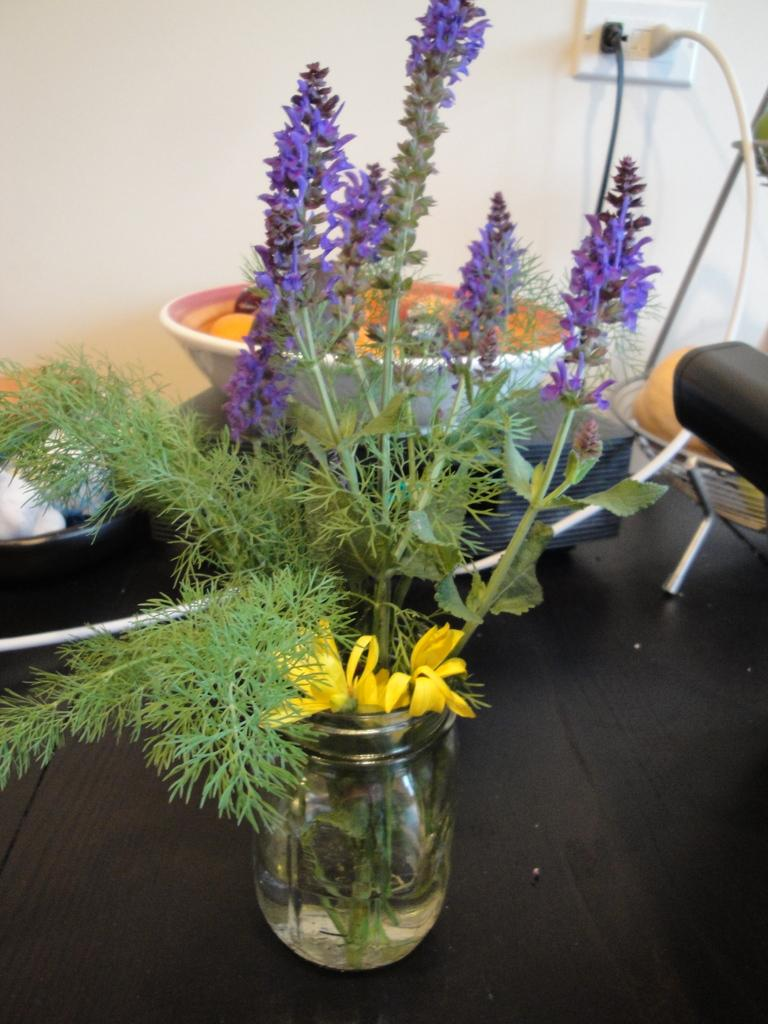What type of plant can be seen in the image? There is a plant with a flower in the image. How is the plant contained or displayed? The plant is in a bottle. What type of furniture is present in the image? There is a table in the image. What type of spot can be seen on the plant after a mass of people walked through the area? There is no mention of a spot, people walking through the area, or a mass in the image. The image only shows a plant with a flower in a bottle and a table. 